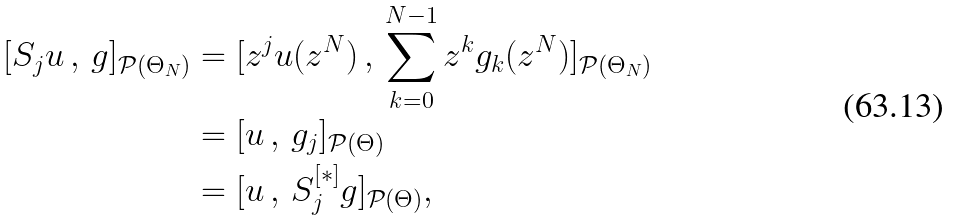<formula> <loc_0><loc_0><loc_500><loc_500>[ S _ { j } u \, , \, g ] _ { \mathcal { P } ( \Theta _ { N } ) } & = [ z ^ { j } u ( z ^ { N } ) \, , \, \sum _ { k = 0 } ^ { N - 1 } z ^ { k } g _ { k } ( z ^ { N } ) ] _ { \mathcal { P } ( \Theta _ { N } ) } \\ & = [ u \, , \, g _ { j } ] _ { \mathcal { P } ( \Theta ) } \\ & = [ u \, , \, S _ { j } ^ { [ * ] } g ] _ { \mathcal { P } ( \Theta ) } ,</formula> 